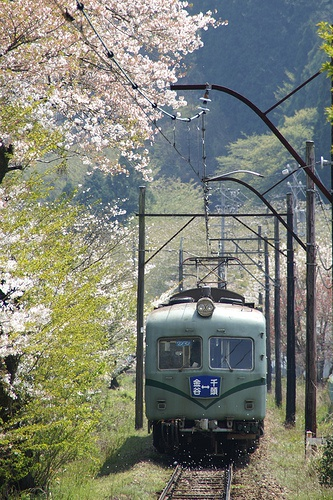Describe the objects in this image and their specific colors. I can see train in gray, black, purple, and white tones and people in gray, black, and purple tones in this image. 